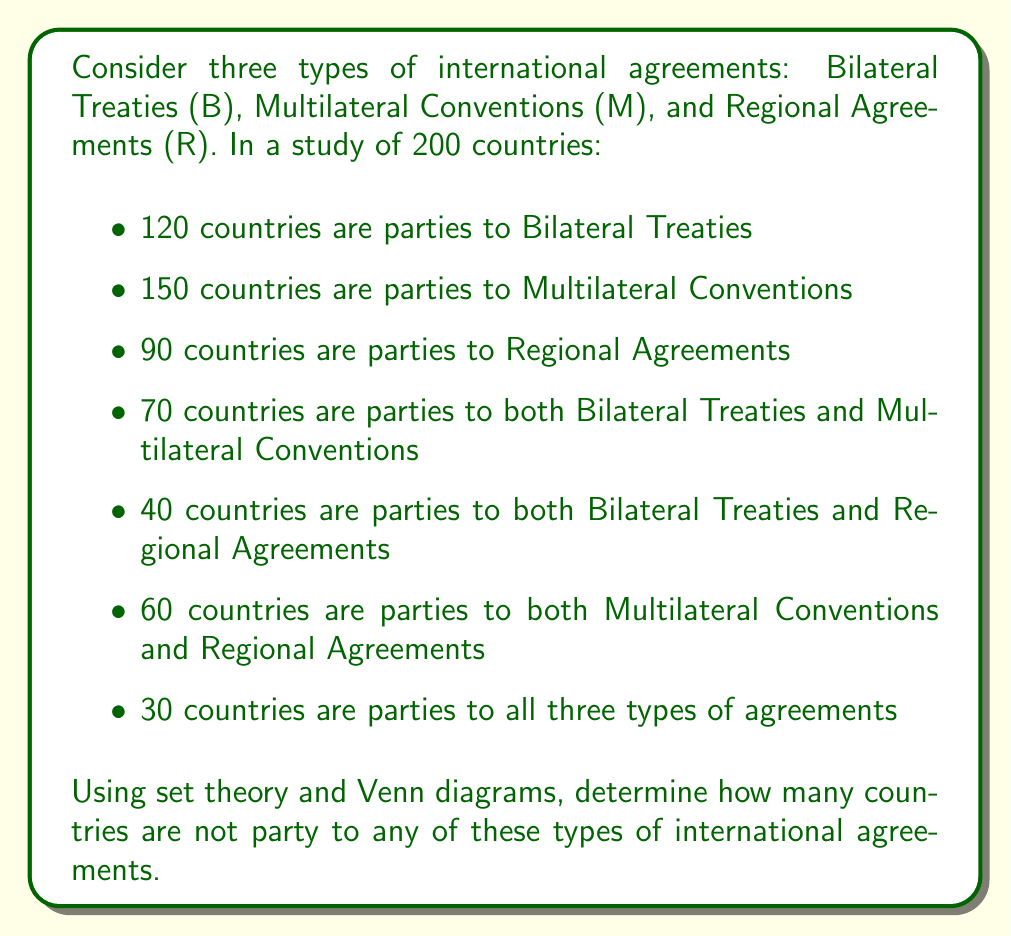Can you answer this question? Let's approach this step-by-step using set theory and a Venn diagram:

1. First, let's draw a Venn diagram with three overlapping circles representing B, M, and R.

[asy]
unitsize(1cm);
pair A = (0,0), B = (1.5,0), C = (0.75,1.3);
real r = 1.2;
draw(circle(A,r));
draw(circle(B,r));
draw(circle(C,r));
label("B", A+(-0.9,-0.9));
label("M", B+(0.9,-0.9));
label("R", C+(0,1.1));
label("30", (0.75,0.43));
label("40", (-0.3,-0.2));
label("60", (1.8,-0.2));
label("70", (0.75,-0.7));
[/asy]

2. We can fill in the known values:
   - 30 in the center (common to all three)
   - 40 in B ∩ R (but not in M)
   - 60 in M ∩ R (but not in B)
   - 70 in B ∩ M (but not in R)

3. Now, let's calculate the unique elements in each set:
   - B only: $120 - (30 + 40 + 70) = -20$
   - M only: $150 - (30 + 60 + 70) = -10$
   - R only: $90 - (30 + 40 + 60) = -40$

4. The negative values indicate that our initial information was inconsistent. This is a common issue in real-world data collection and analysis, particularly in international relations where information can be complex and sometimes contradictory.

5. To proceed, we need to use the principle of inclusion-exclusion:

   $$|B ∪ M ∪ R| = |B| + |M| + |R| - |B ∩ M| - |B ∩ R| - |M ∩ R| + |B ∩ M ∩ R|$$

6. Substituting the known values:

   $$|B ∪ M ∪ R| = 120 + 150 + 90 - 70 - 40 - 60 + 30 = 220$$

7. This means that 220 countries are party to at least one of these agreements.

8. Given that there are 200 countries in total, we have an overcount of 20. This further confirms the inconsistency in our initial data.

9. Despite this inconsistency, we can still answer the question by assuming that all 200 countries are accounted for in our data about agreement participation.

10. Therefore, the number of countries not party to any of these agreements is:

    $$200 - 220 = -20$$
Answer: The data provided is inconsistent, leading to a negative result. Assuming all 200 countries are accounted for in the agreement data, there are no countries (-20) that are not party to any of these types of international agreements. This result highlights the importance of data verification and the complexities of analyzing international relations data. 